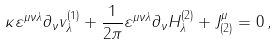<formula> <loc_0><loc_0><loc_500><loc_500>\kappa \varepsilon ^ { \mu \nu \lambda } \partial _ { \nu } v _ { \lambda } ^ { ( 1 ) } + \frac { 1 } { 2 \pi } \varepsilon ^ { \mu \nu \lambda } \partial _ { \nu } H ^ { ( 2 ) } _ { \lambda } + J ^ { \mu } _ { ( 2 ) } = 0 \, ,</formula> 